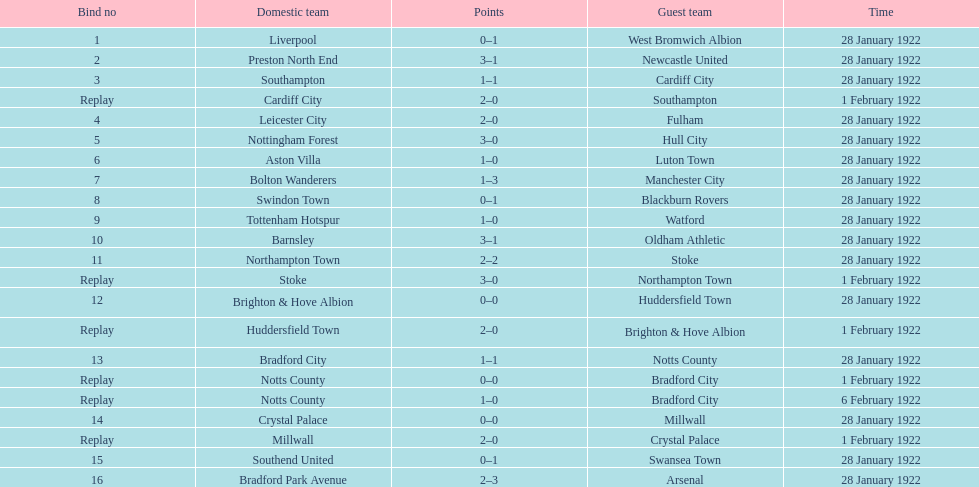In how many games were four or more total points scored? 5. 